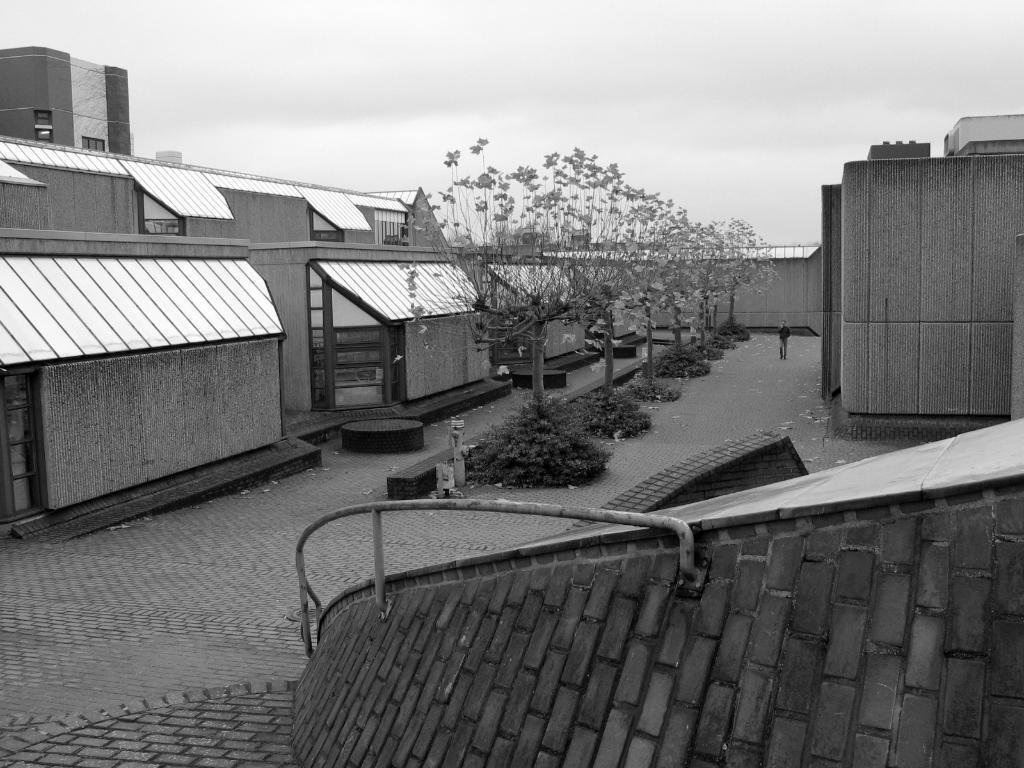Can you describe this image briefly? In this image I can see a fence at the front. There are trees and a person is present at the center. There are buildings and this is a black and white image. 